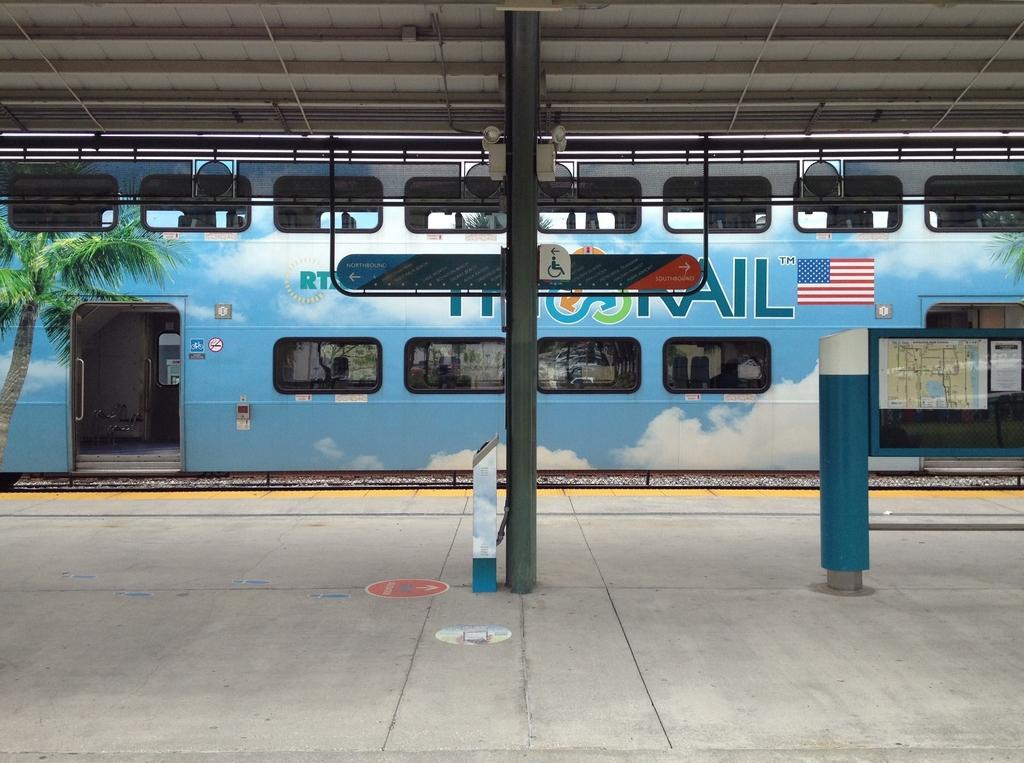How would you summarize this image in a sentence or two? In this image I can see a platform, pole, windows and a train on the track. This image is taken during a day on the platform. 